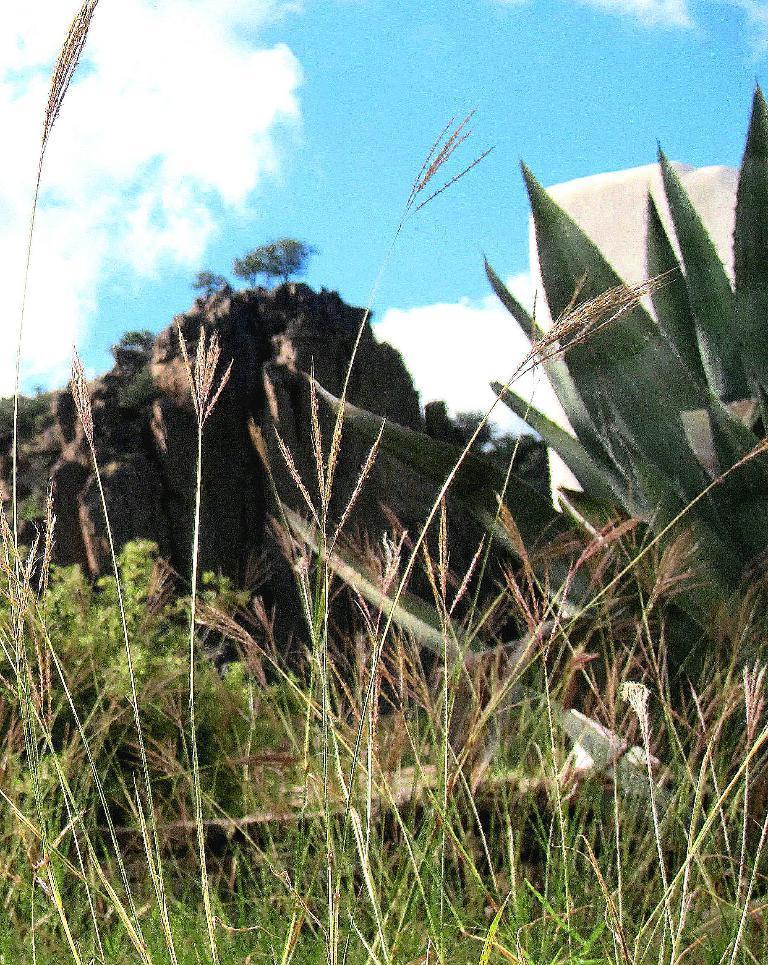Please provide a concise description of this image. In this picture I can see the grass and plants in front and in the background I can see the rocks, few trees and the sky. 